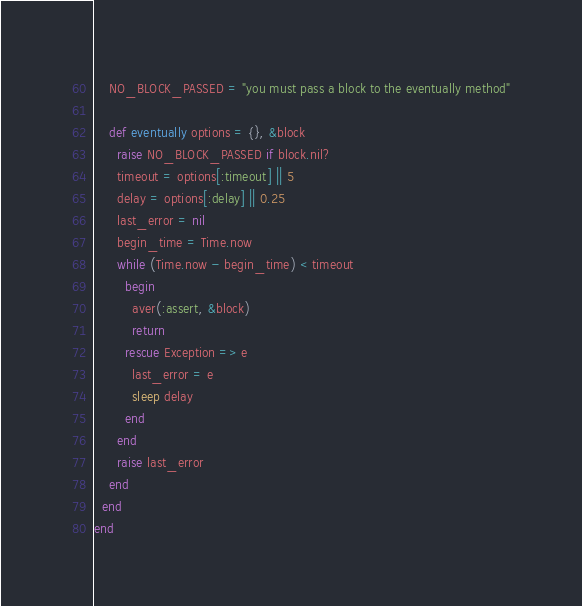Convert code to text. <code><loc_0><loc_0><loc_500><loc_500><_Ruby_>    NO_BLOCK_PASSED = "you must pass a block to the eventually method"
    
    def eventually options = {}, &block
      raise NO_BLOCK_PASSED if block.nil?
      timeout = options[:timeout] || 5
      delay = options[:delay] || 0.25
      last_error = nil
      begin_time = Time.now      
      while (Time.now - begin_time) < timeout
        begin
          aver(:assert, &block)
          return
        rescue Exception => e
          last_error = e
          sleep delay
        end
      end
      raise last_error
    end
  end
end
</code> 